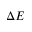<formula> <loc_0><loc_0><loc_500><loc_500>\Delta E</formula> 